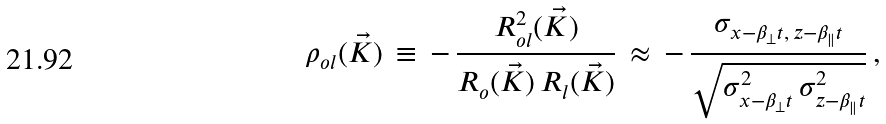<formula> <loc_0><loc_0><loc_500><loc_500>\rho _ { o l } ( \vec { K } ) \, \equiv \, - \, \frac { R _ { o l } ^ { 2 } ( \vec { K } ) } { R _ { o } ( \vec { K } ) \, R _ { l } ( \vec { K } ) } \, \approx \, - \, \frac { \sigma _ { x - \beta _ { \perp } t , \, z - \beta _ { \| } t } } { \sqrt { \sigma _ { x - \beta _ { \perp } t } ^ { 2 } \, \sigma _ { z - \beta _ { \| } t } ^ { 2 } } } \, ,</formula> 